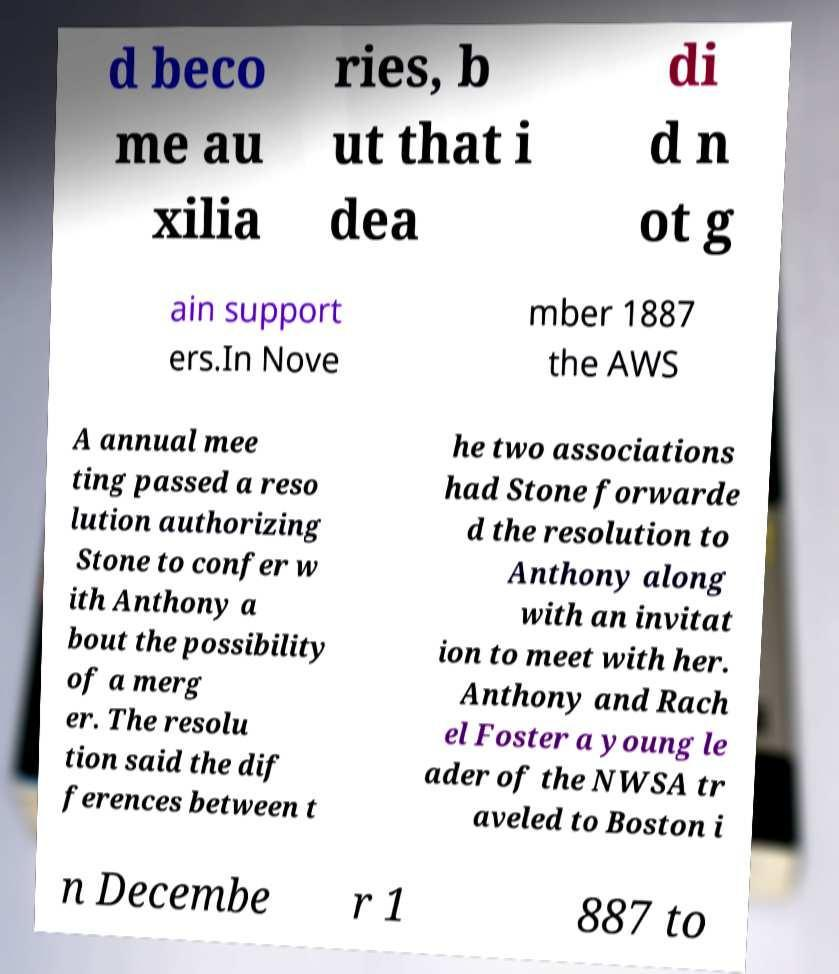Can you accurately transcribe the text from the provided image for me? d beco me au xilia ries, b ut that i dea di d n ot g ain support ers.In Nove mber 1887 the AWS A annual mee ting passed a reso lution authorizing Stone to confer w ith Anthony a bout the possibility of a merg er. The resolu tion said the dif ferences between t he two associations had Stone forwarde d the resolution to Anthony along with an invitat ion to meet with her. Anthony and Rach el Foster a young le ader of the NWSA tr aveled to Boston i n Decembe r 1 887 to 